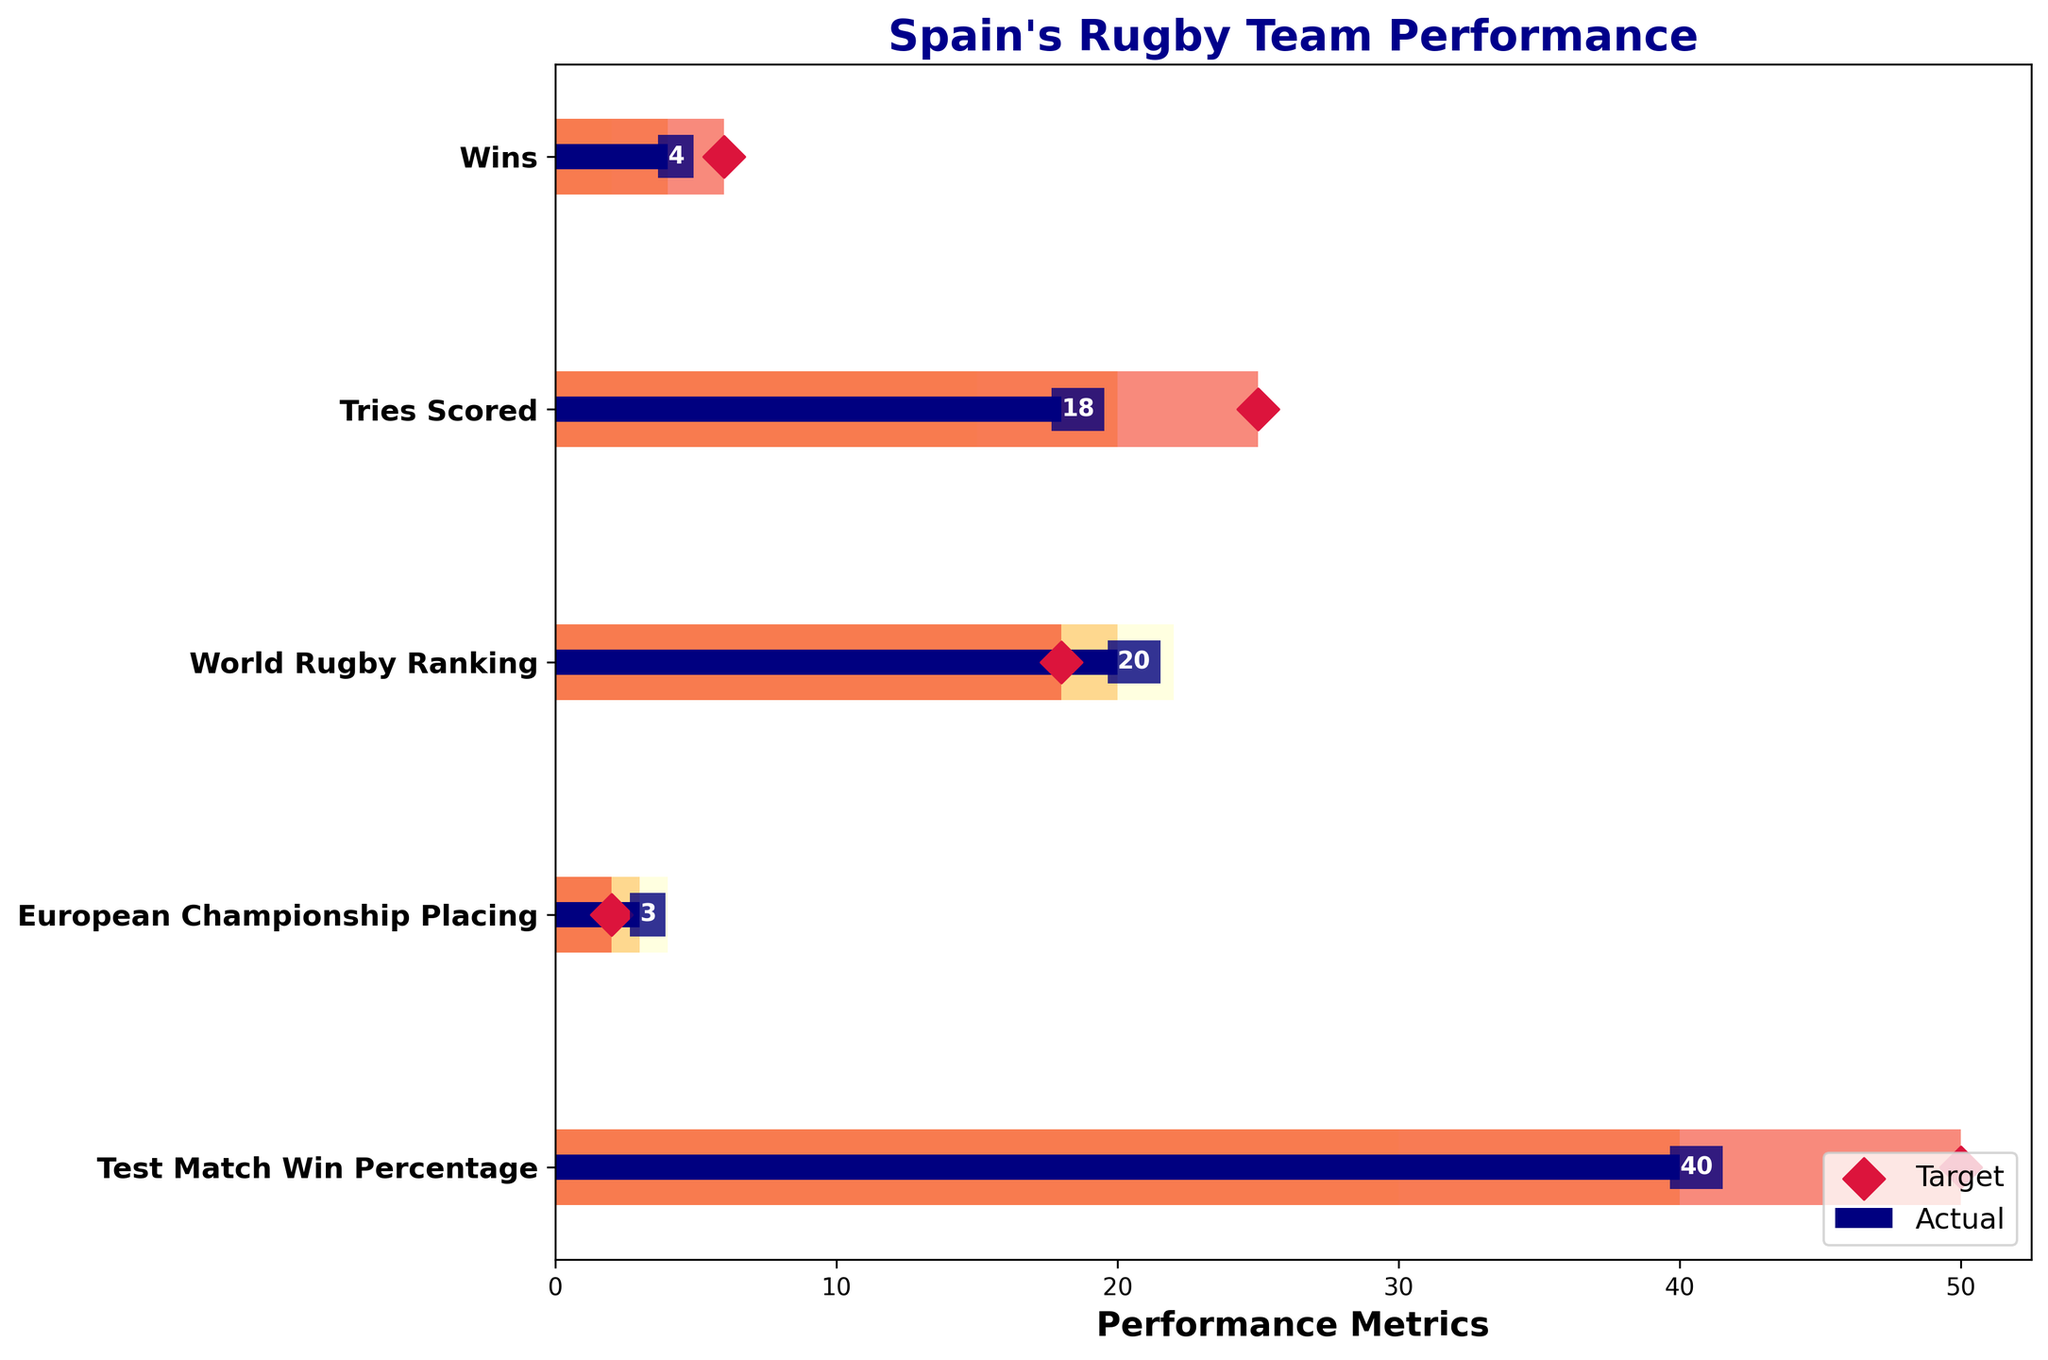What's the title of the chart? The title of the chart is displayed prominently at the top of the figure. It helps viewers understand what the chart is about.
Answer: Spain's Rugby Team Performance How many categories are analyzed in this chart? The chart uses six horizontal bars to represent different performance metrics. Count each unique category label to find the total number.
Answer: 5 What is Spain's actual ranking in the World Rugby Ranking category? The "World Rugby Ranking" category has a horizontal bar plotted for the actual performance. Find the value inside this bar.
Answer: 20 What is the difference between the target ranking and the actual ranking in the World Rugby Ranking category? Subtract the actual ranking value in the "World Rugby Ranking" category from the target ranking value displayed as a red diamond.
Answer: -2 Which category has the smallest gap between the actual value and the target value? For each category, calculate the difference between the actual and target values. Identify the category with the smallest difference.
Answer: European Championship Placing In which category did Spain exceed the Range 1 threshold but not the Range 2 threshold? Check each category's actual bar against the different range bars. Identify the one where the actual is above Range 1 but below Range 2.
Answer: Wins How does Spain's performance in Test Match Win Percentage compare to its target? Compare the actual percentage bar in "Test Match Win Percentage" with the red diamond target value. Describe whether it is below, at, or above the target.
Answer: Below Which category shows the highest actual value achieved by Spain? Compare the actual values across all categories and identify the highest one.
Answer: Tries Scored What's the total sum of actual values in all categories? Sum the actual values shown inside the bars across all categories: 4 + 18 + 20 + 3 + 40.
Answer: 85 If Spain's target wins for the next season were set 1 win lower, what would the new difference between the actual and target wins be? The target for wins is 6. Reducing it by 1 makes it 5. Find the difference between the actual and new target: 4 - 5.
Answer: -1 